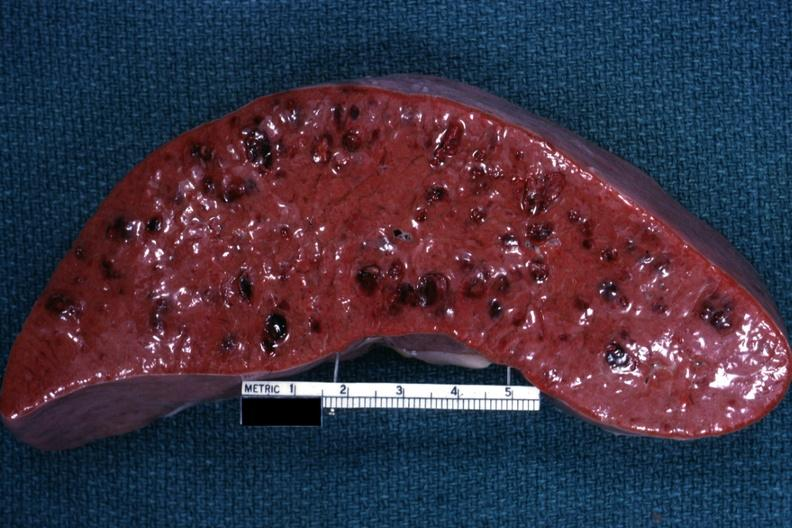what is present?
Answer the question using a single word or phrase. Hematologic 